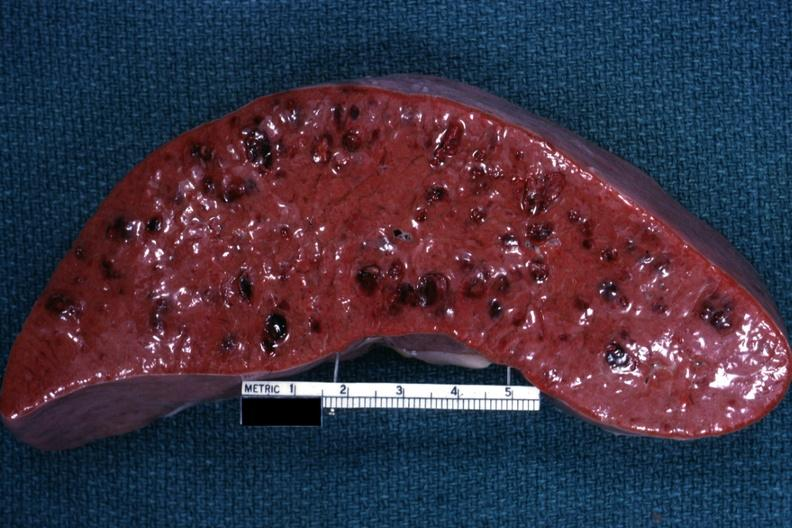what is present?
Answer the question using a single word or phrase. Hematologic 